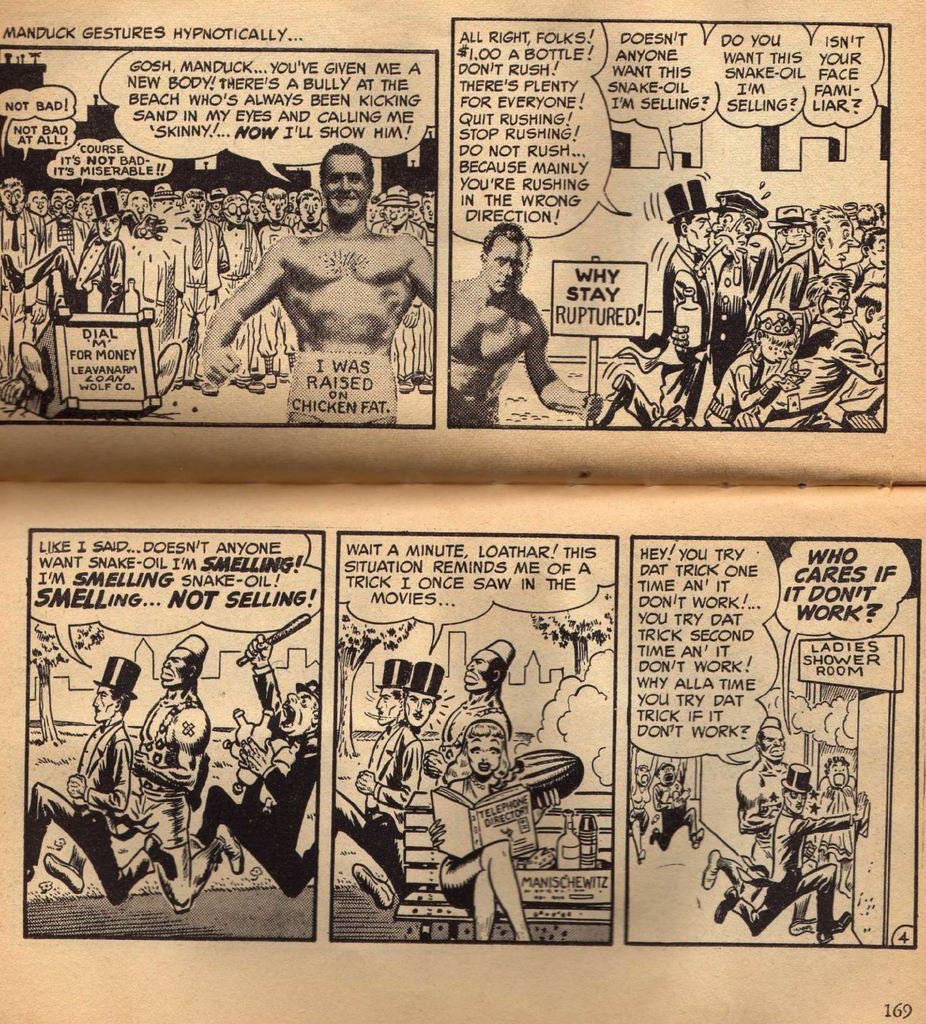<image>
Create a compact narrative representing the image presented. a comic that says ' manduck gestures hypnotically' on it 